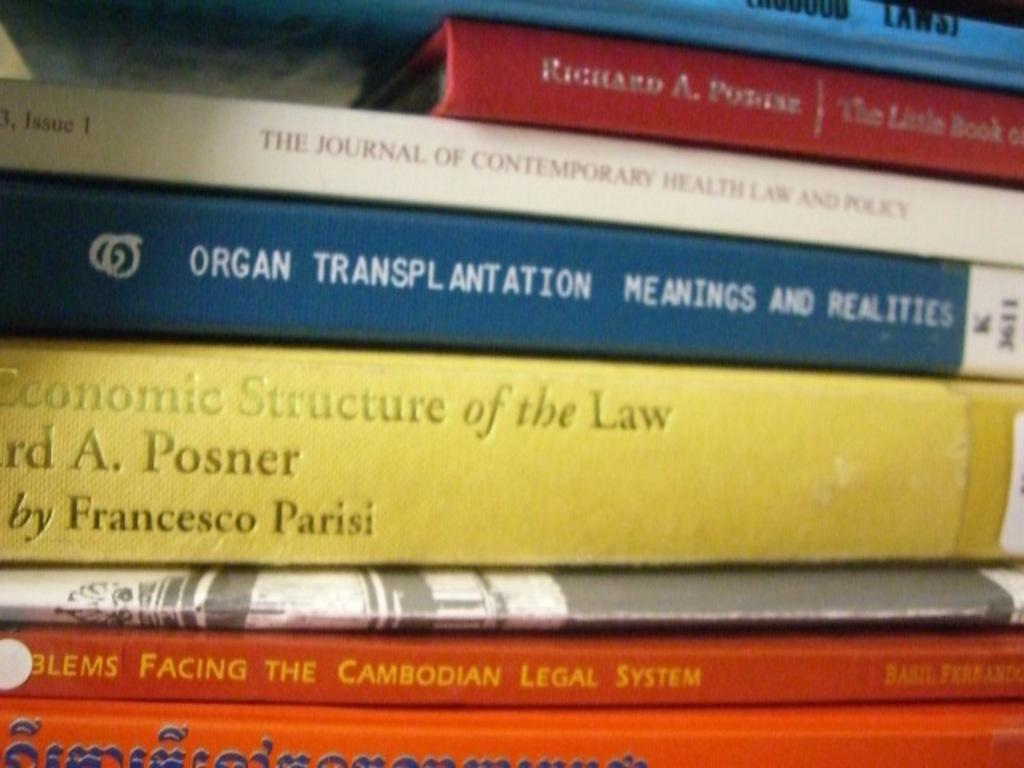Provide a one-sentence caption for the provided image. A stack of books includes one on organ transplantation. 